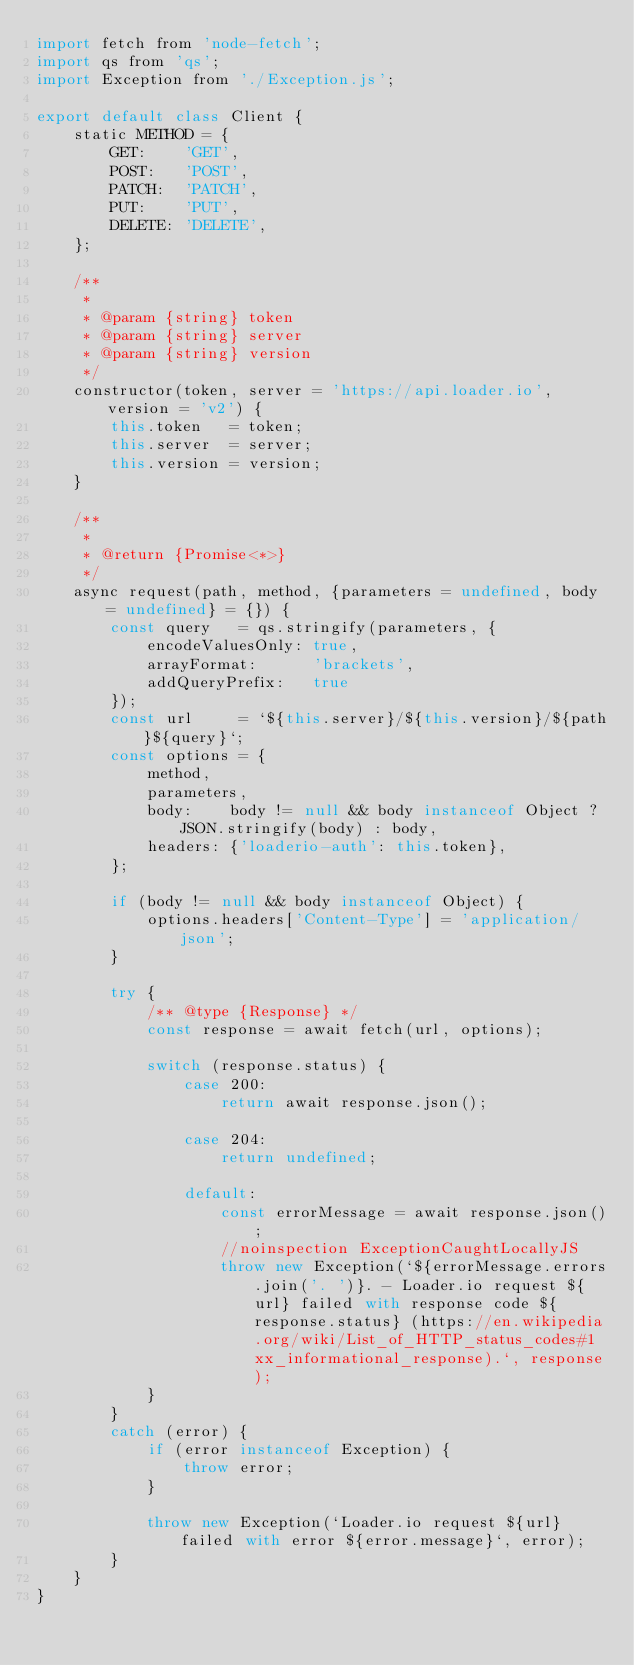Convert code to text. <code><loc_0><loc_0><loc_500><loc_500><_JavaScript_>import fetch from 'node-fetch';
import qs from 'qs';
import Exception from './Exception.js';

export default class Client {
    static METHOD = {
        GET:    'GET',
        POST:   'POST',
        PATCH:  'PATCH',
        PUT:    'PUT',
        DELETE: 'DELETE',
    };

    /**
     *
     * @param {string} token
     * @param {string} server
     * @param {string} version
     */
    constructor(token, server = 'https://api.loader.io', version = 'v2') {
        this.token   = token;
        this.server  = server;
        this.version = version;
    }

    /**
     *
     * @return {Promise<*>}
     */
    async request(path, method, {parameters = undefined, body = undefined} = {}) {
        const query   = qs.stringify(parameters, {
            encodeValuesOnly: true,
            arrayFormat:      'brackets',
            addQueryPrefix:   true
        });
        const url     = `${this.server}/${this.version}/${path}${query}`;
        const options = {
            method,
            parameters,
            body:    body != null && body instanceof Object ? JSON.stringify(body) : body,
            headers: {'loaderio-auth': this.token},
        };

        if (body != null && body instanceof Object) {
            options.headers['Content-Type'] = 'application/json';
        }

        try {
            /** @type {Response} */
            const response = await fetch(url, options);

            switch (response.status) {
                case 200:
                    return await response.json();

                case 204:
                    return undefined;

                default:
                    const errorMessage = await response.json();
                    //noinspection ExceptionCaughtLocallyJS
                    throw new Exception(`${errorMessage.errors.join('. ')}. - Loader.io request ${url} failed with response code ${response.status} (https://en.wikipedia.org/wiki/List_of_HTTP_status_codes#1xx_informational_response).`, response);
            }
        }
        catch (error) {
            if (error instanceof Exception) {
                throw error;
            }

            throw new Exception(`Loader.io request ${url} failed with error ${error.message}`, error);
        }
    }
}
</code> 